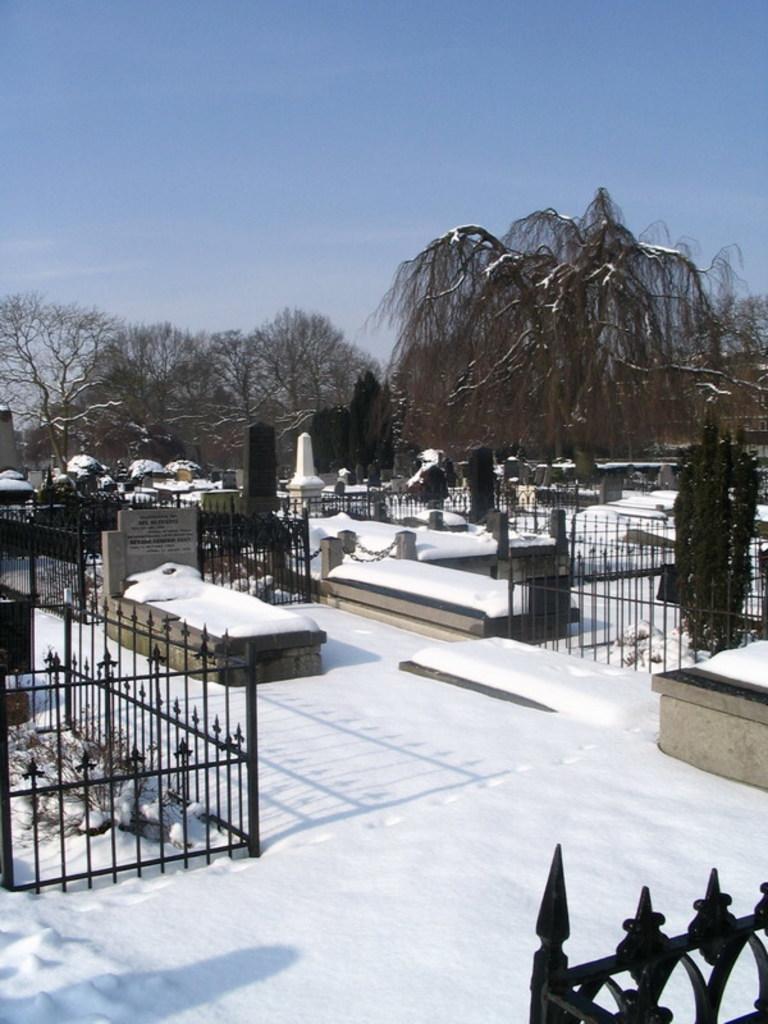Describe this image in one or two sentences. In this picture, it seems to be there are graves in the center of the image on the snow floor and there are headstones and boundaries in the image and there are trees in the background area of the image. 